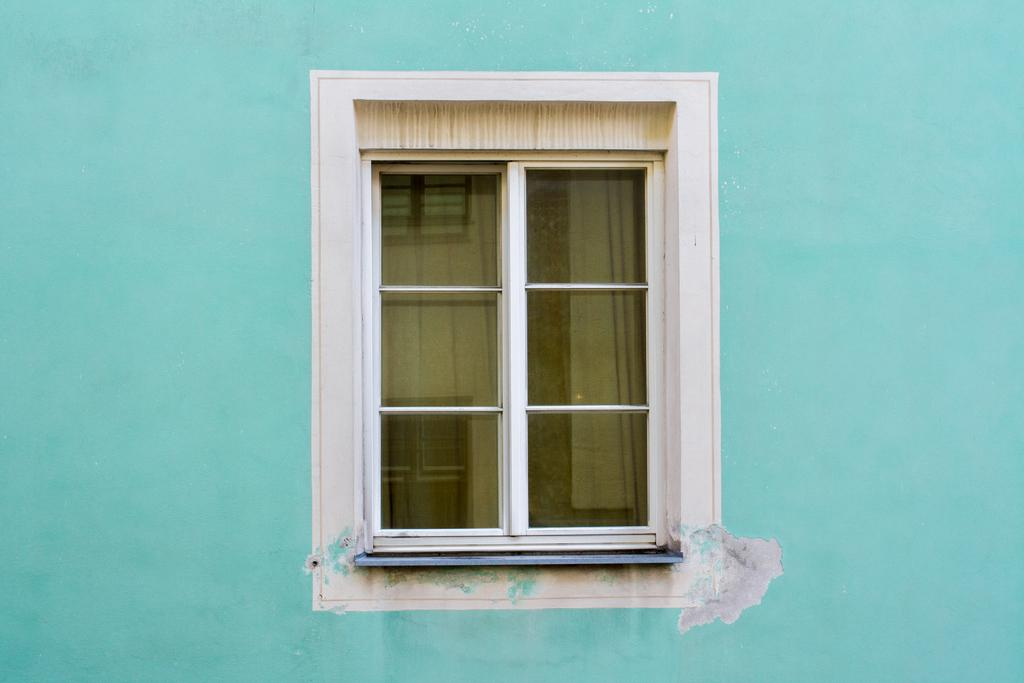What color is the wall in the image? The wall in the image is blue. What type of window is present in the image? There is a glass window in the image. What can be seen in the reflection of the glass window? The glass window has a reflection of the windows. What type of picture is hanging on the side of the blue wall in the image? There is no picture hanging on the side of the blue wall in the image. What season is depicted in the image? The provided facts do not mention any season or weather-related details, so it cannot be determined from the image. 